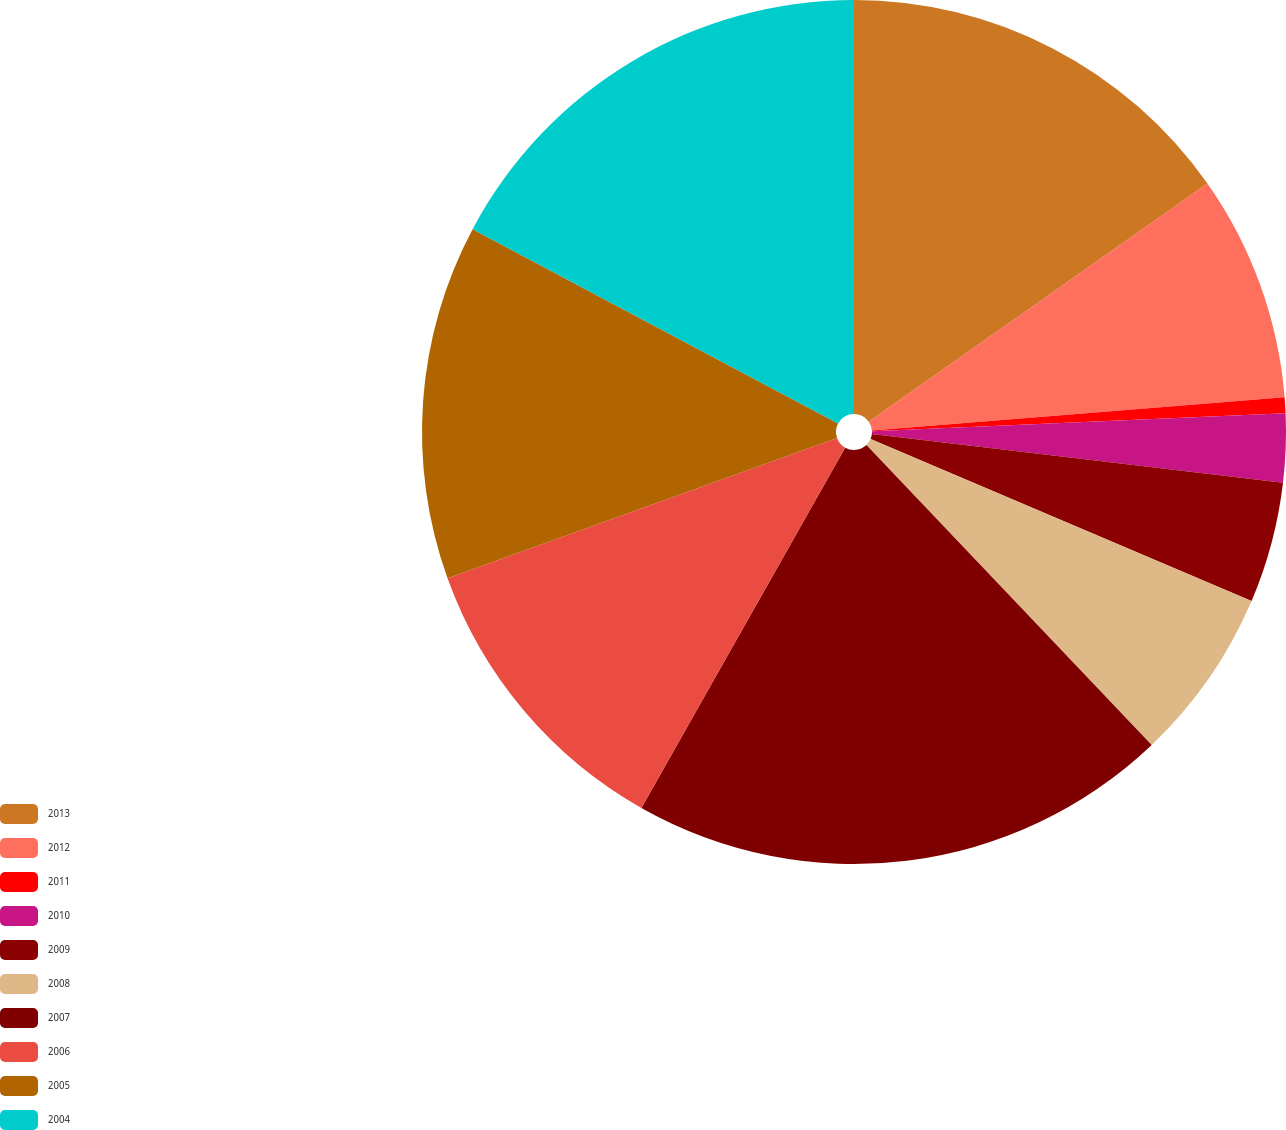<chart> <loc_0><loc_0><loc_500><loc_500><pie_chart><fcel>2013<fcel>2012<fcel>2011<fcel>2010<fcel>2009<fcel>2008<fcel>2007<fcel>2006<fcel>2005<fcel>2004<nl><fcel>15.25%<fcel>8.47%<fcel>0.59%<fcel>2.56%<fcel>4.53%<fcel>6.5%<fcel>20.29%<fcel>11.31%<fcel>13.28%<fcel>17.22%<nl></chart> 